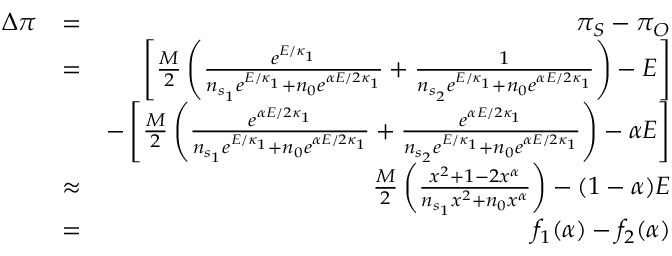Convert formula to latex. <formula><loc_0><loc_0><loc_500><loc_500>\begin{array} { r l r } { \Delta \pi } & { = } & { \pi _ { S } - \pi _ { O } } \\ & { = } & { \left [ \frac { M } { 2 } \left ( \frac { e ^ { E / \kappa _ { 1 } } } { n _ { s _ { 1 } } e ^ { E / \kappa _ { 1 } } + n _ { 0 } e ^ { \alpha E / 2 \kappa _ { 1 } } } + \frac { 1 } { n _ { s _ { 2 } } e ^ { E / \kappa _ { 1 } } + n _ { 0 } e ^ { \alpha E / 2 \kappa _ { 1 } } } \right ) - E \right ] } \\ & { - \left [ \frac { M } { 2 } \left ( \frac { e ^ { \alpha E / 2 \kappa _ { 1 } } } { n _ { s _ { 1 } } e ^ { E / \kappa _ { 1 } } + n _ { 0 } e ^ { \alpha E / 2 \kappa _ { 1 } } } + \frac { e ^ { \alpha E / 2 \kappa _ { 1 } } } { n _ { s _ { 2 } } e ^ { E / \kappa _ { 1 } } + n _ { 0 } e ^ { \alpha E / 2 \kappa _ { 1 } } } \right ) - \alpha E \right ] } \\ & { \approx } & { \frac { M } { 2 } \left ( \frac { x ^ { 2 } + 1 - 2 x ^ { \alpha } } { n _ { s _ { 1 } } x ^ { 2 } + n _ { 0 } x ^ { \alpha } } \right ) - ( 1 - \alpha ) E } \\ & { = } & { f _ { 1 } ( \alpha ) - f _ { 2 } ( \alpha ) } \end{array}</formula> 